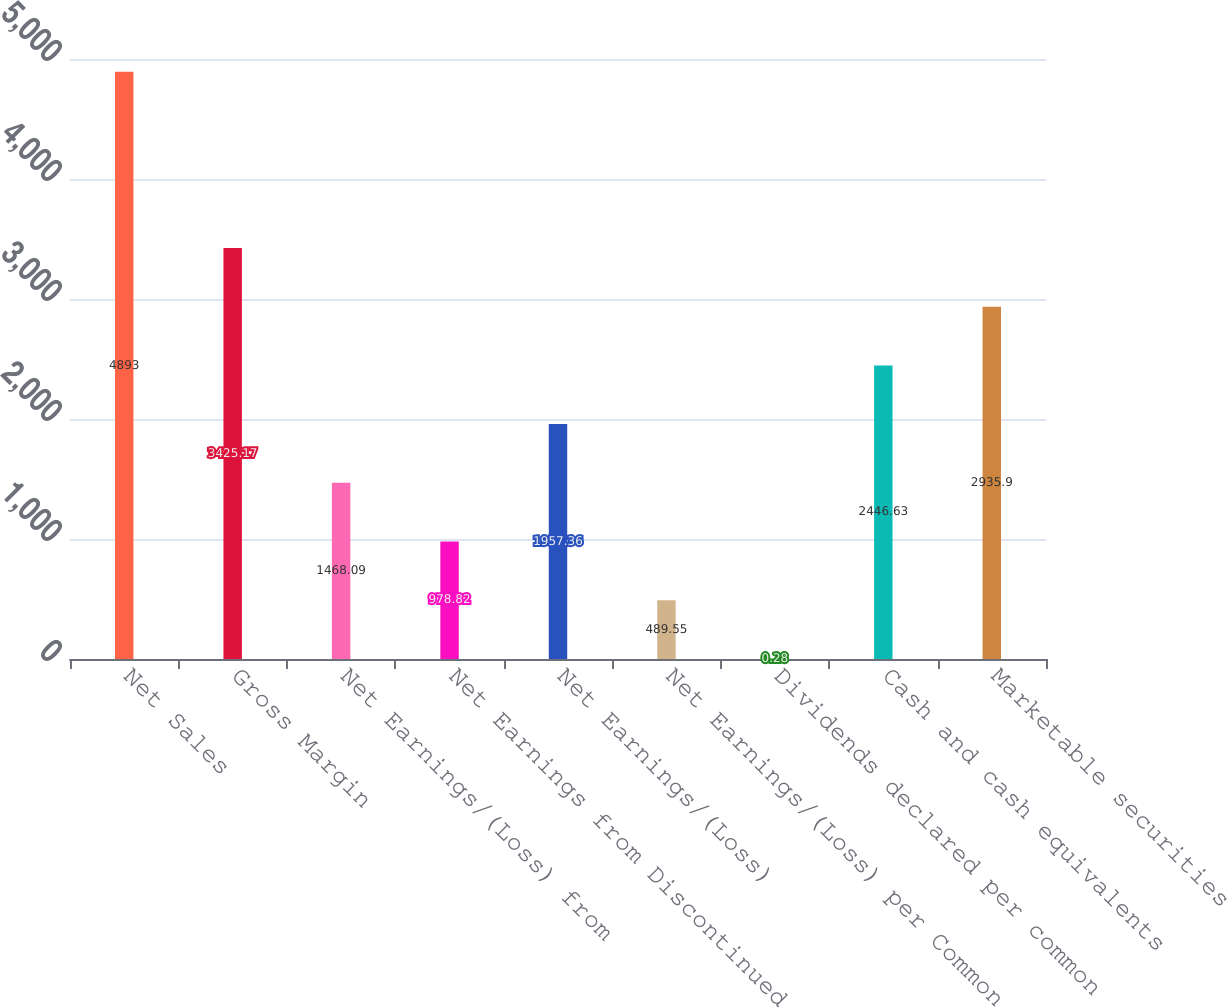Convert chart to OTSL. <chart><loc_0><loc_0><loc_500><loc_500><bar_chart><fcel>Net Sales<fcel>Gross Margin<fcel>Net Earnings/(Loss) from<fcel>Net Earnings from Discontinued<fcel>Net Earnings/(Loss)<fcel>Net Earnings/(Loss) per Common<fcel>Dividends declared per common<fcel>Cash and cash equivalents<fcel>Marketable securities<nl><fcel>4893<fcel>3425.17<fcel>1468.09<fcel>978.82<fcel>1957.36<fcel>489.55<fcel>0.28<fcel>2446.63<fcel>2935.9<nl></chart> 